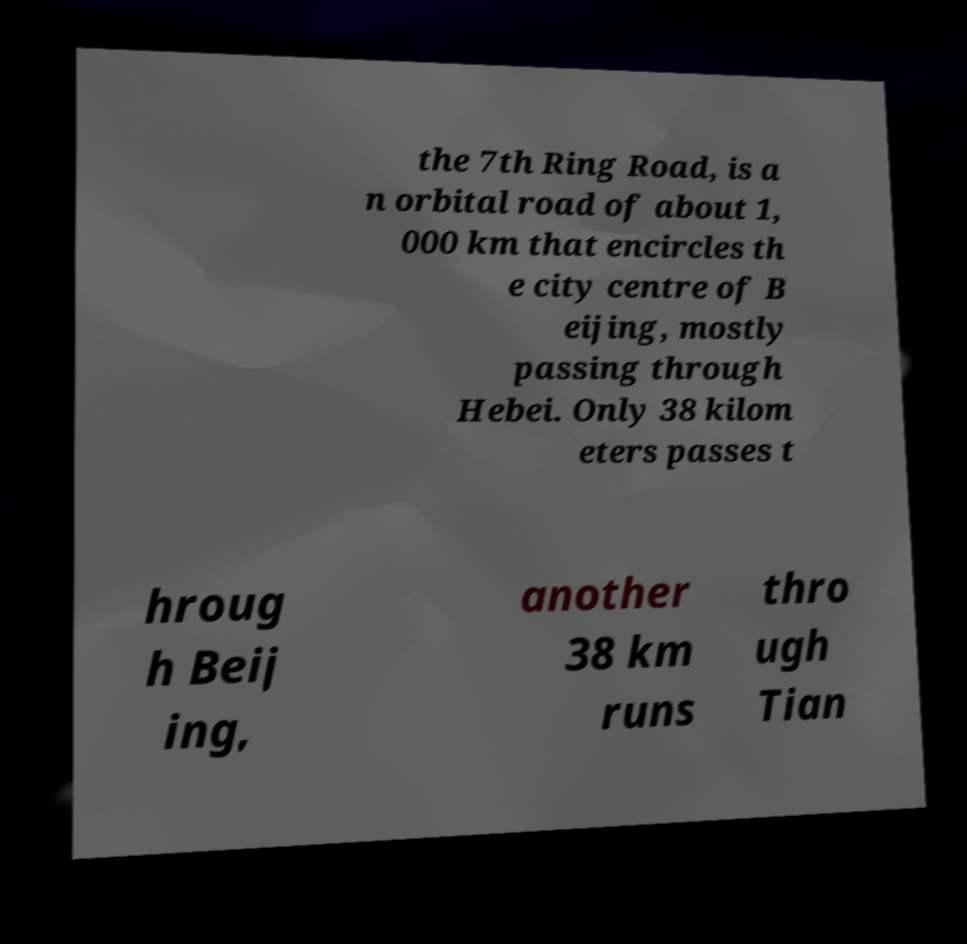What messages or text are displayed in this image? I need them in a readable, typed format. the 7th Ring Road, is a n orbital road of about 1, 000 km that encircles th e city centre of B eijing, mostly passing through Hebei. Only 38 kilom eters passes t hroug h Beij ing, another 38 km runs thro ugh Tian 